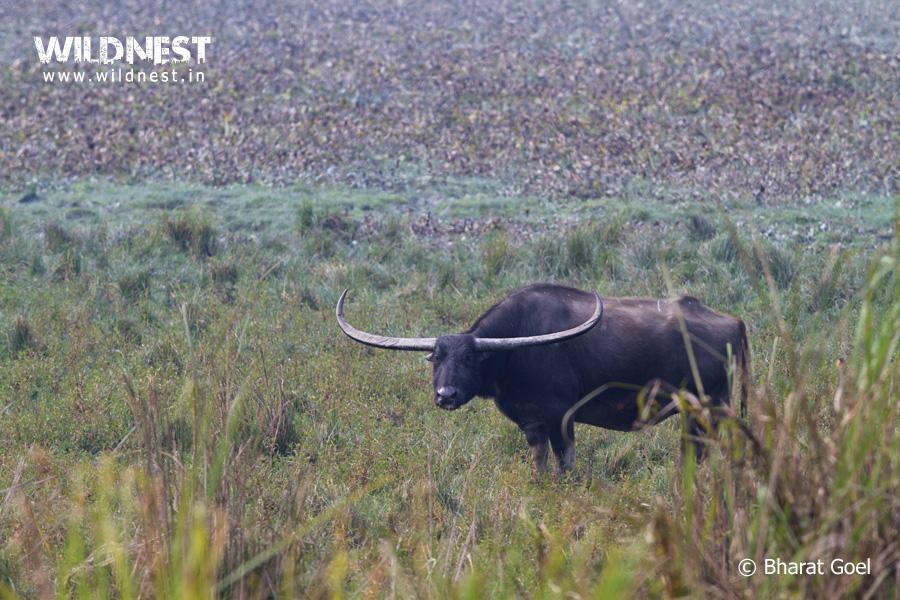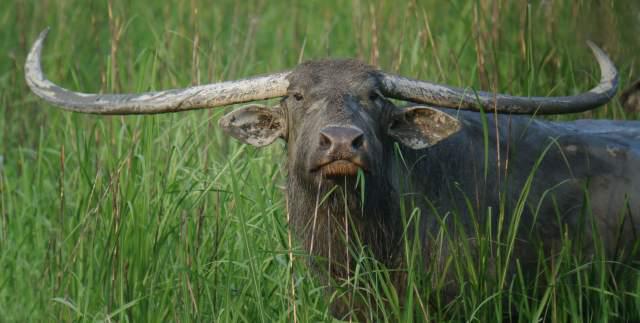The first image is the image on the left, the second image is the image on the right. Evaluate the accuracy of this statement regarding the images: "There are more animals in the image on the right than in the image on the left.". Is it true? Answer yes or no. No. The first image is the image on the left, the second image is the image on the right. Given the left and right images, does the statement "Left image shows one water buffalo standing in profile, with body turned leftward." hold true? Answer yes or no. Yes. 